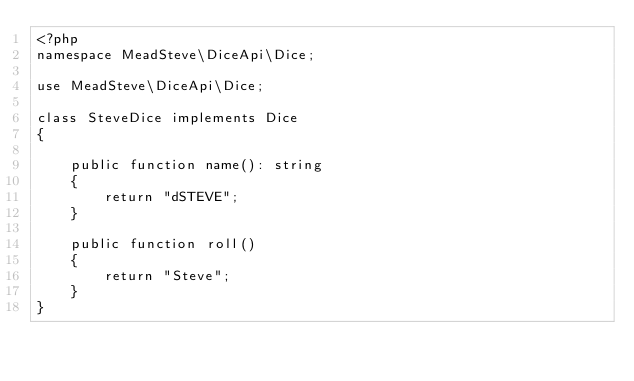Convert code to text. <code><loc_0><loc_0><loc_500><loc_500><_PHP_><?php
namespace MeadSteve\DiceApi\Dice;

use MeadSteve\DiceApi\Dice;

class SteveDice implements Dice
{

    public function name(): string
    {
        return "dSTEVE";
    }

    public function roll()
    {
        return "Steve";
    }
}
</code> 